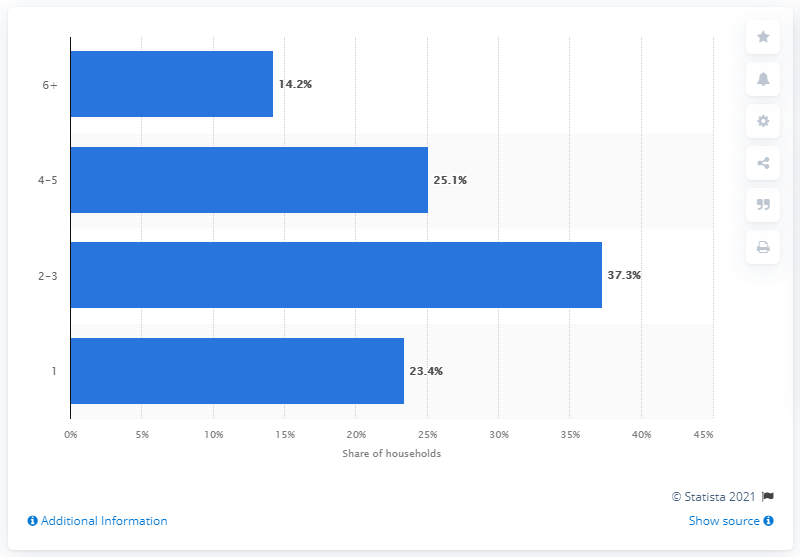Draw attention to some important aspects in this diagram. According to data from the 2011 South Africa census, approximately 14.2% of the country's population is comprised of households with six or more people. In 2019, 23.4% of South African households were single person households. 